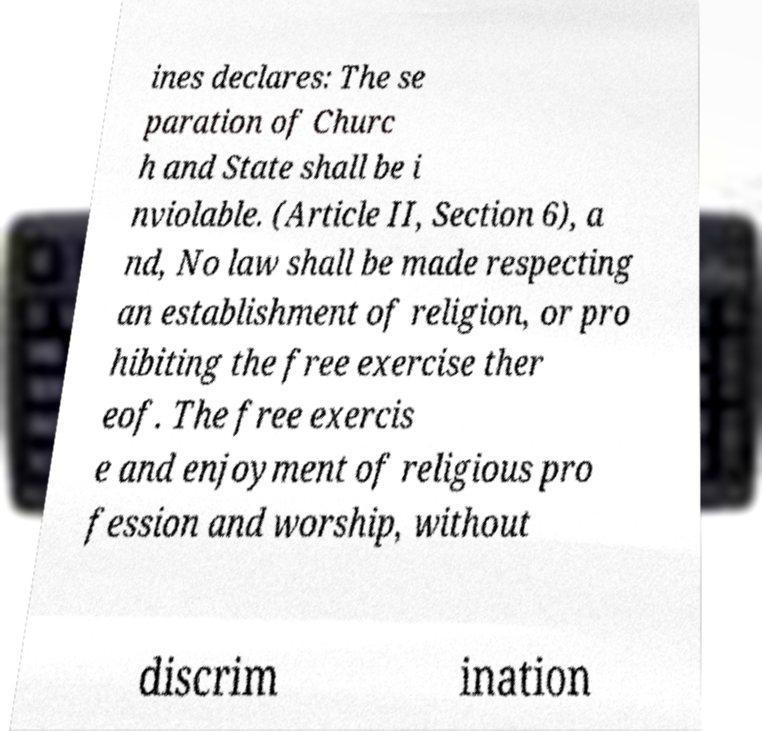Could you assist in decoding the text presented in this image and type it out clearly? ines declares: The se paration of Churc h and State shall be i nviolable. (Article II, Section 6), a nd, No law shall be made respecting an establishment of religion, or pro hibiting the free exercise ther eof. The free exercis e and enjoyment of religious pro fession and worship, without discrim ination 